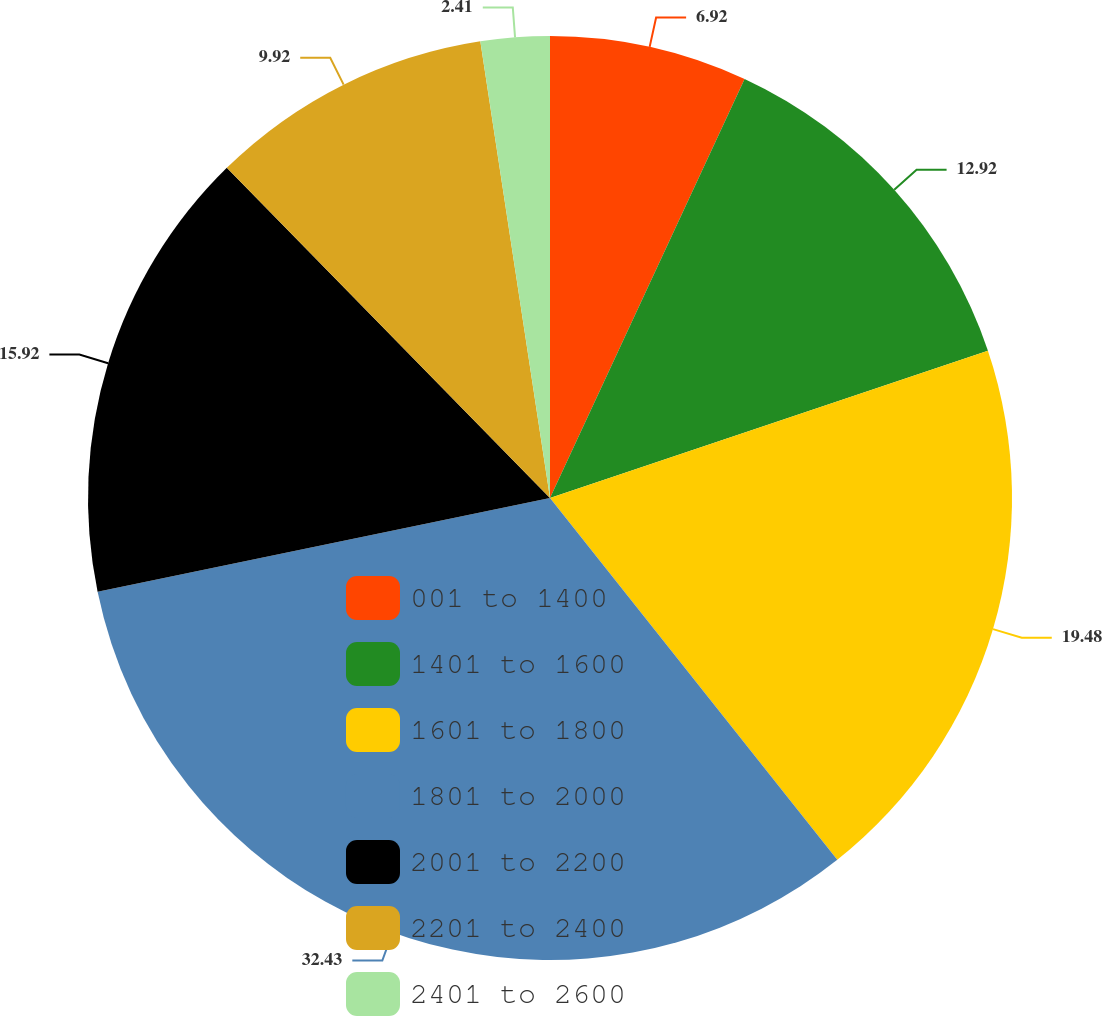Convert chart to OTSL. <chart><loc_0><loc_0><loc_500><loc_500><pie_chart><fcel>001 to 1400<fcel>1401 to 1600<fcel>1601 to 1800<fcel>1801 to 2000<fcel>2001 to 2200<fcel>2201 to 2400<fcel>2401 to 2600<nl><fcel>6.92%<fcel>12.92%<fcel>19.48%<fcel>32.43%<fcel>15.92%<fcel>9.92%<fcel>2.41%<nl></chart> 